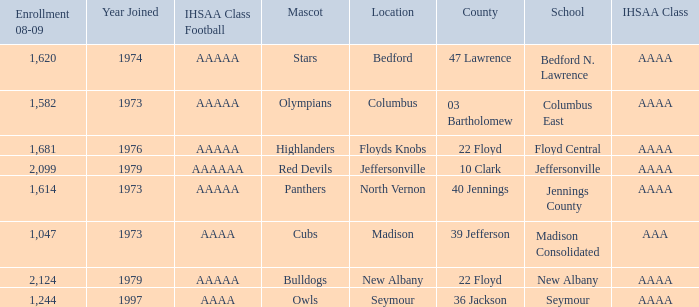What's the IHSAA Class when the school is Seymour? AAAA. 